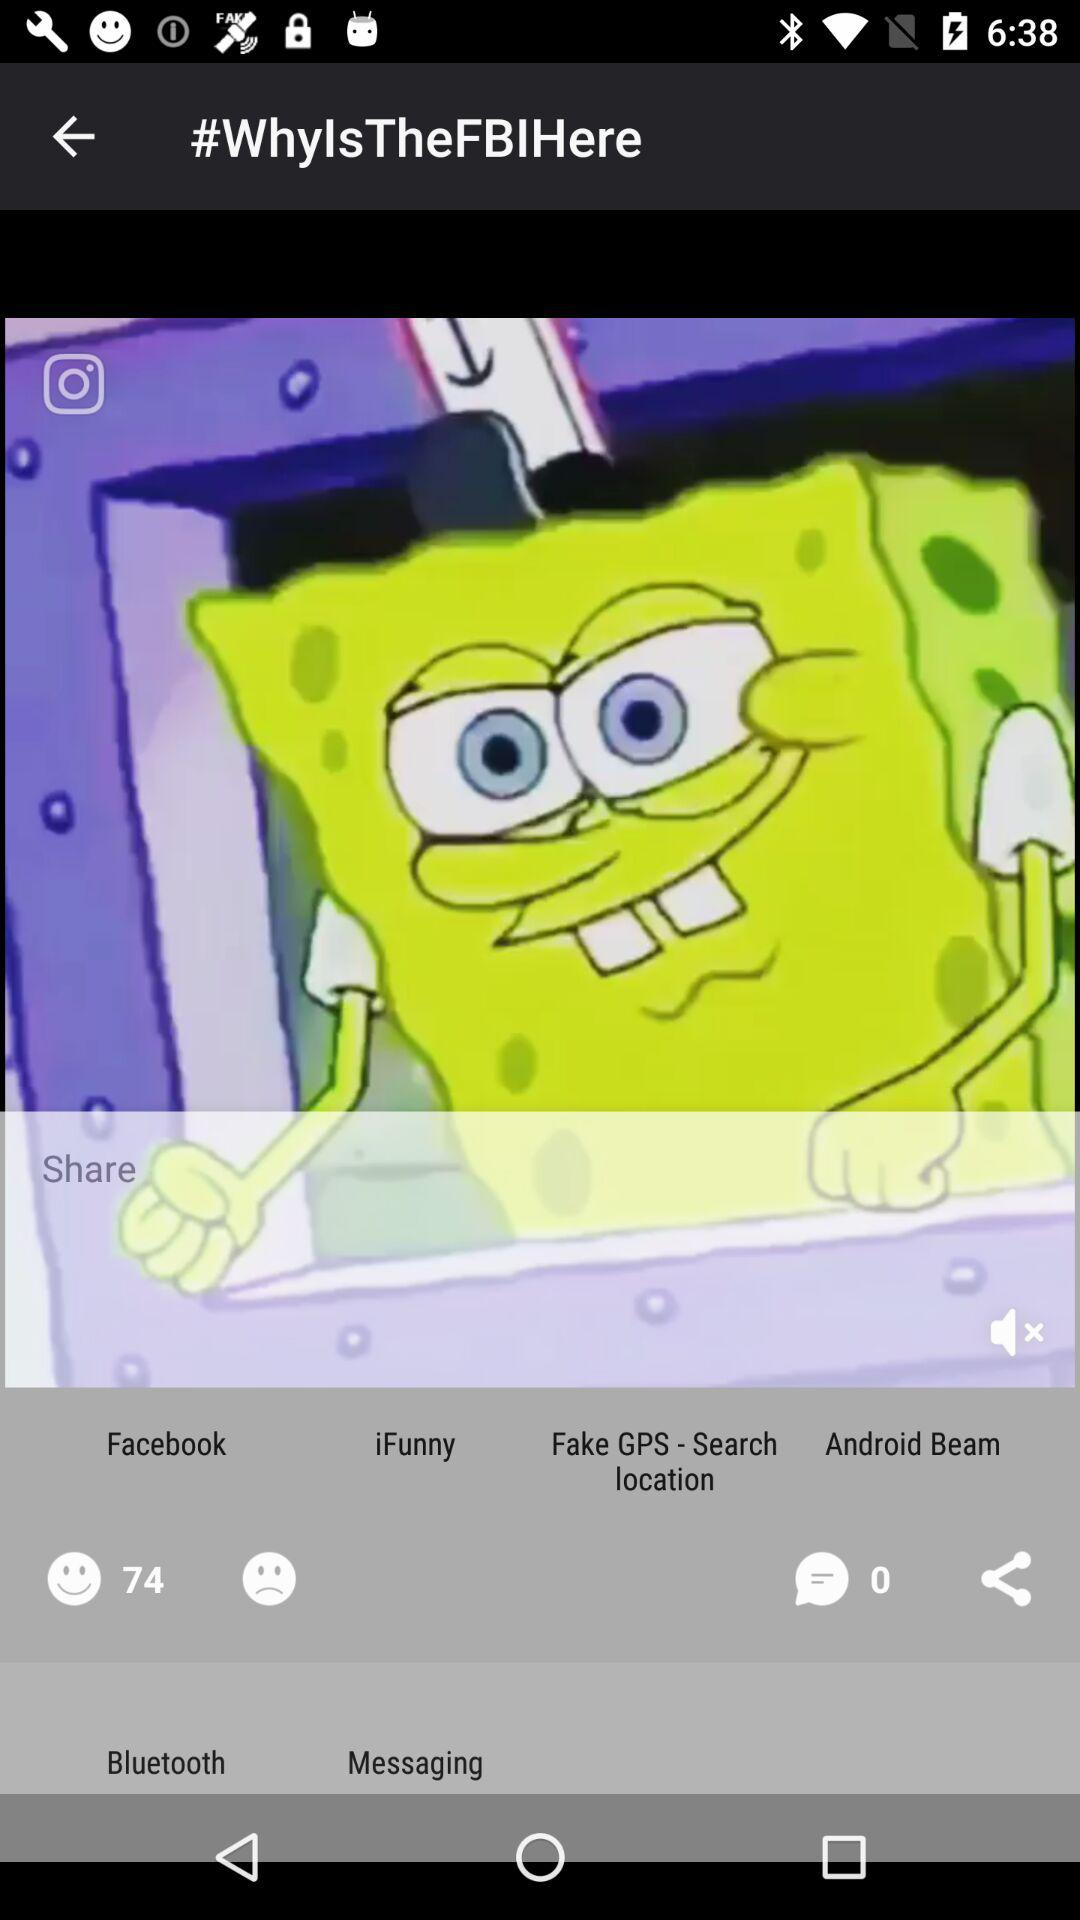What is the number of comments? The number of comments is 0. 